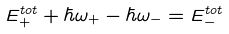<formula> <loc_0><loc_0><loc_500><loc_500>E ^ { t o t } _ { + } + \hbar { \omega } _ { + } - \hbar { \omega } _ { - } = E ^ { t o t } _ { - }</formula> 